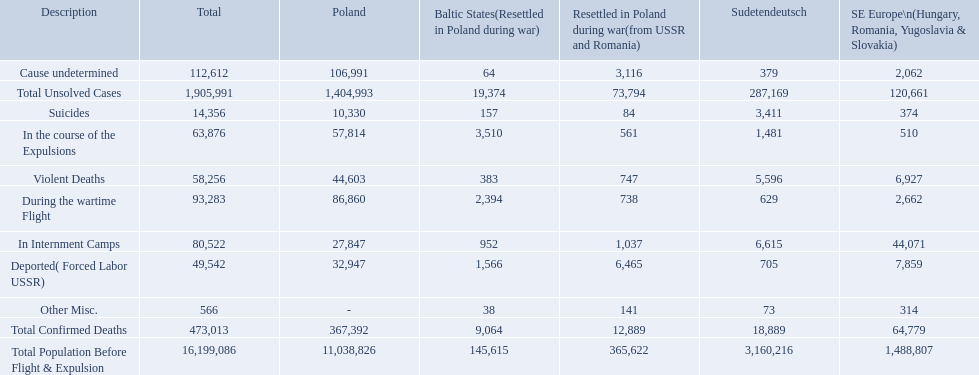What were the total number of confirmed deaths? 473,013. Of these, how many were violent? 58,256. How many deaths did the baltic states have in each category? 145,615, 383, 157, 1,566, 952, 2,394, 3,510, 64, 38, 9,064, 19,374. How many cause undetermined deaths did baltic states have? 64. How many other miscellaneous deaths did baltic states have? 38. Which is higher in deaths, cause undetermined or other miscellaneous? Cause undetermined. 